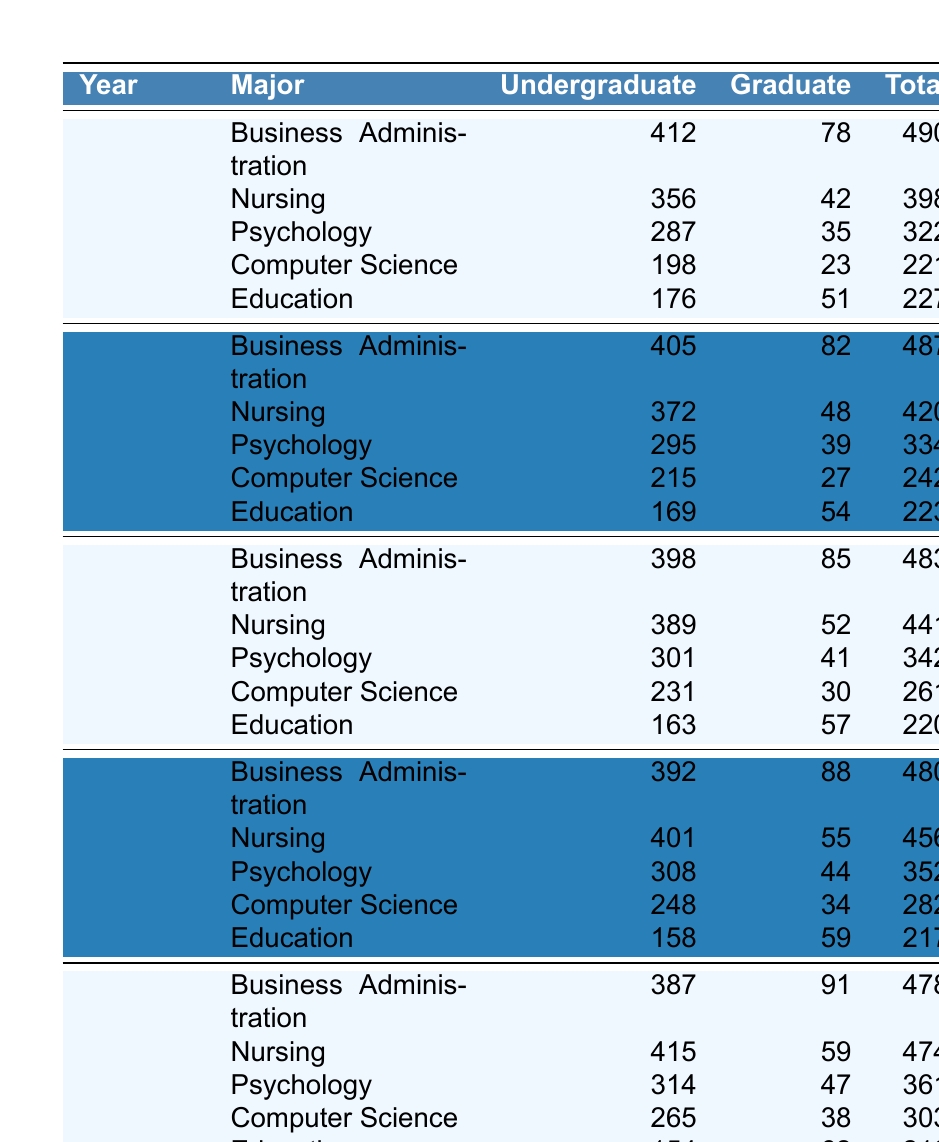What was the total enrollment for Nursing in 2021? In the year 2021, the total enrollment for Nursing is directly listed in the table as 441.
Answer: 441 Which major had the highest total enrollment in 2020? By comparing the total enrollment values for each major in 2020, Business Administration had a total of 487, which is the highest among the listed majors.
Answer: Business Administration What was the change in total enrollment for Psychology from 2019 to 2023? The total enrollment for Psychology in 2019 was 322, and in 2023 it was 361. The change is calculated as 361 - 322 = 39.
Answer: 39 Is the total undergraduate enrollment for Computer Science greater in 2021 than in 2022? In 2021, the undergraduate enrollment for Computer Science is 231, while in 2022 it is 248. Since 231 is less than 248, the statement is false.
Answer: No Which major experienced the highest increase in graduate enrollment from 2019 to 2023? The graduate enrollment for each major was analyzed: Business Administration (78 to 91, increase of 13), Nursing (42 to 59, increase of 17), Psychology (35 to 47, increase of 12), Computer Science (23 to 38, increase of 15), and Education (51 to 62, increase of 11). The highest increase was for Nursing, with an increase of 17.
Answer: Nursing What is the average total enrollment across all majors in 2022? The total enrollments for each major in 2022 are 480, 456, 352, 282, and 217. Adding these gives 480 + 456 + 352 + 282 + 217 = 1787. Dividing by the number of majors (5), the average total enrollment is 1787 / 5 = 357.4.
Answer: 357.4 Which major had the lowest undergraduate enrollment in 2020? By comparing the undergraduate enrollments in 2020, the values are 405 (Business Administration), 372 (Nursing), 295 (Psychology), 215 (Computer Science), and 169 (Education). Education has the lowest enrollment at 169.
Answer: Education Did the total enrollment for Business Administration decrease from 2020 to 2023? The total enrollment for Business Administration in 2020 was 487, and in 2023 it was 478. Since 478 is less than 487, the total enrollment did decrease.
Answer: Yes What is the difference in total enrollment between the years 2019 and 2022 for all majors combined? The total enrollment for 2019 is 490 + 398 + 322 + 221 + 227 = 1658. For 2022, it is 480 + 456 + 352 + 282 + 217 = 1787. The difference is 1787 - 1658 = 129.
Answer: 129 